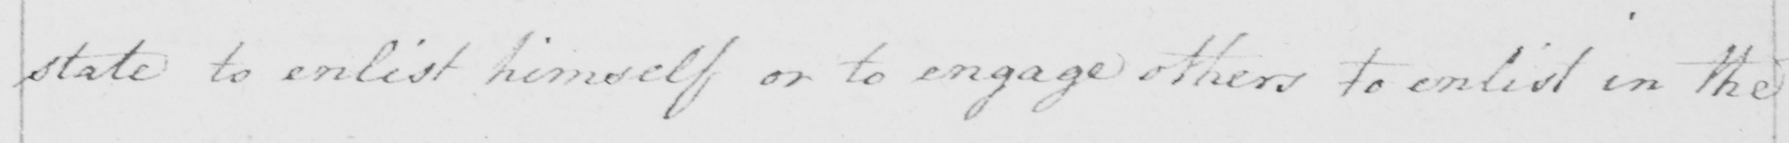Can you tell me what this handwritten text says? state to enlist himself or to engage others to enlist in the 